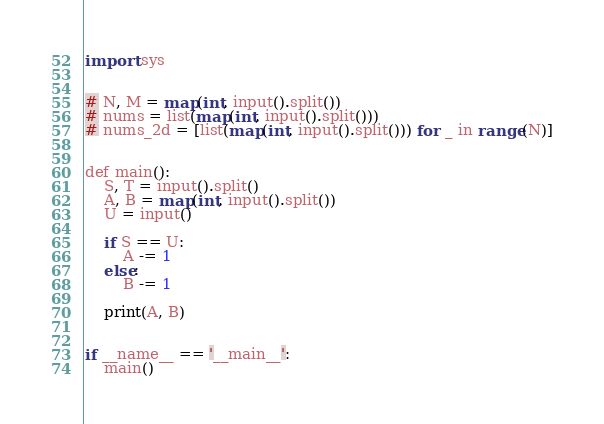<code> <loc_0><loc_0><loc_500><loc_500><_Go_>import sys


# N, M = map(int, input().split())
# nums = list(map(int, input().split()))
# nums_2d = [list(map(int, input().split())) for _ in range(N)]


def main():
    S, T = input().split()
    A, B = map(int, input().split())
    U = input()

    if S == U:
        A -= 1
    else:
        B -= 1

    print(A, B)


if __name__ == '__main__':
    main()
</code> 